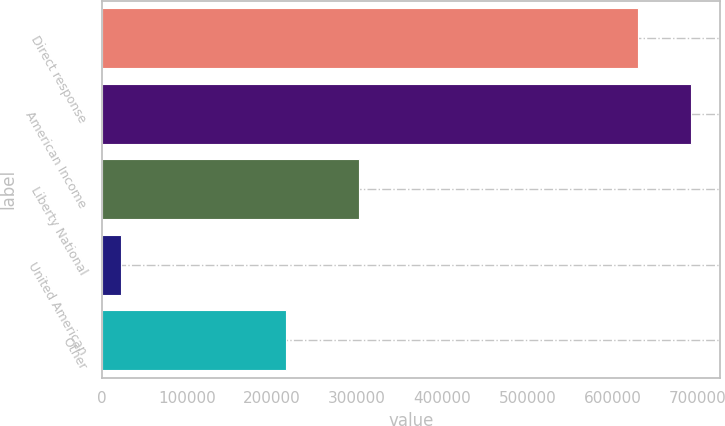Convert chart to OTSL. <chart><loc_0><loc_0><loc_500><loc_500><bar_chart><fcel>Direct response<fcel>American Income<fcel>Liberty National<fcel>United American<fcel>Other<nl><fcel>630044<fcel>692104<fcel>302489<fcel>22203<fcel>216166<nl></chart> 